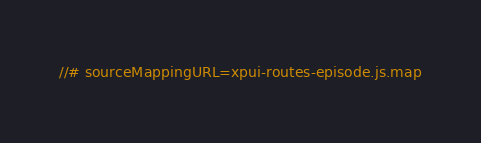Convert code to text. <code><loc_0><loc_0><loc_500><loc_500><_JavaScript_>//# sourceMappingURL=xpui-routes-episode.js.map</code> 